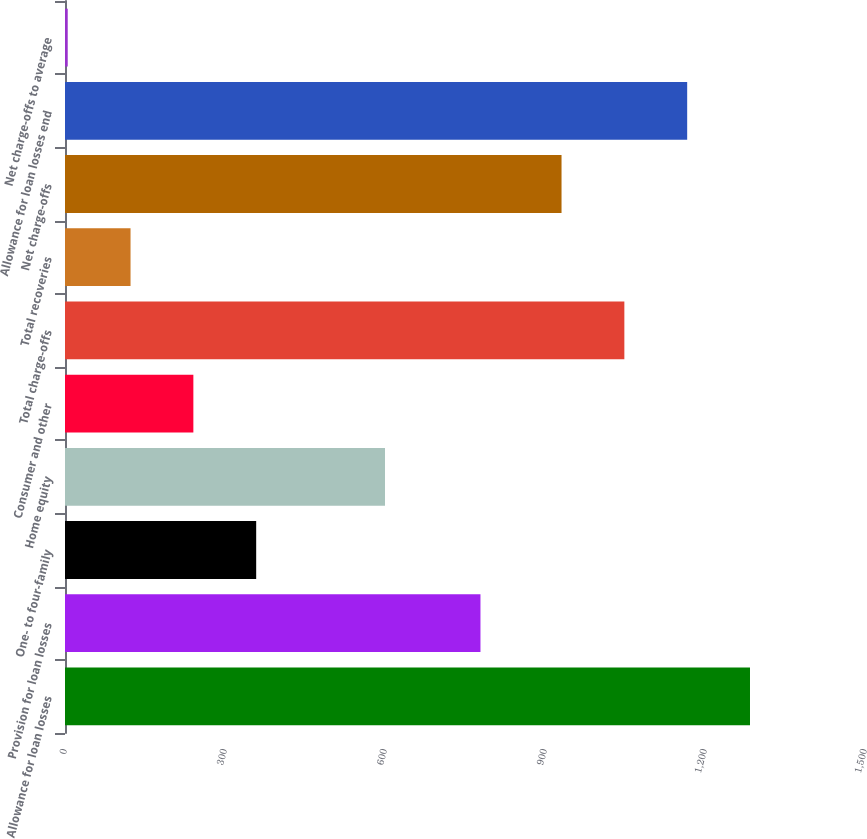<chart> <loc_0><loc_0><loc_500><loc_500><bar_chart><fcel>Allowance for loan losses<fcel>Provision for loan losses<fcel>One- to four-family<fcel>Home equity<fcel>Consumer and other<fcel>Total charge-offs<fcel>Total recoveries<fcel>Net charge-offs<fcel>Allowance for loan losses end<fcel>Net charge-offs to average<nl><fcel>1284.37<fcel>779<fcel>358.47<fcel>600<fcel>240.68<fcel>1048.79<fcel>122.89<fcel>931<fcel>1166.58<fcel>5.1<nl></chart> 